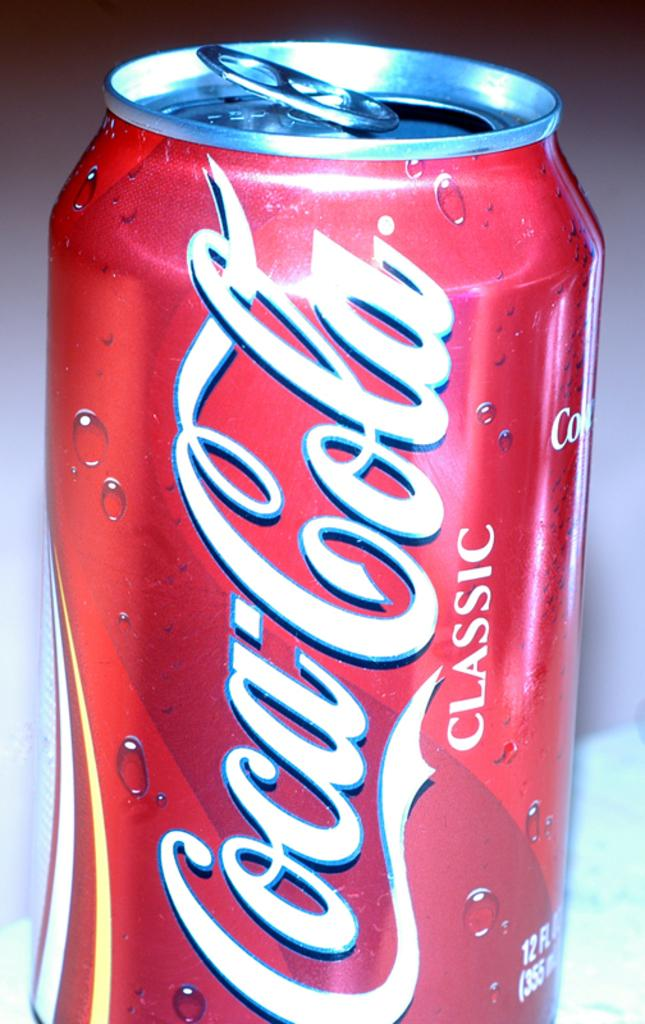<image>
Summarize the visual content of the image. A can of Coca Cola Classic is seen in close up. 